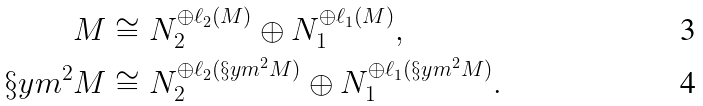<formula> <loc_0><loc_0><loc_500><loc_500>M & \cong N _ { 2 } ^ { \oplus \ell _ { 2 } ( M ) } \oplus N _ { 1 } ^ { \oplus \ell _ { 1 } ( M ) } , \\ \S y m ^ { 2 } M & \cong N _ { 2 } ^ { \oplus \ell _ { 2 } ( \S y m ^ { 2 } M ) } \oplus N _ { 1 } ^ { \oplus \ell _ { 1 } ( \S y m ^ { 2 } M ) } .</formula> 